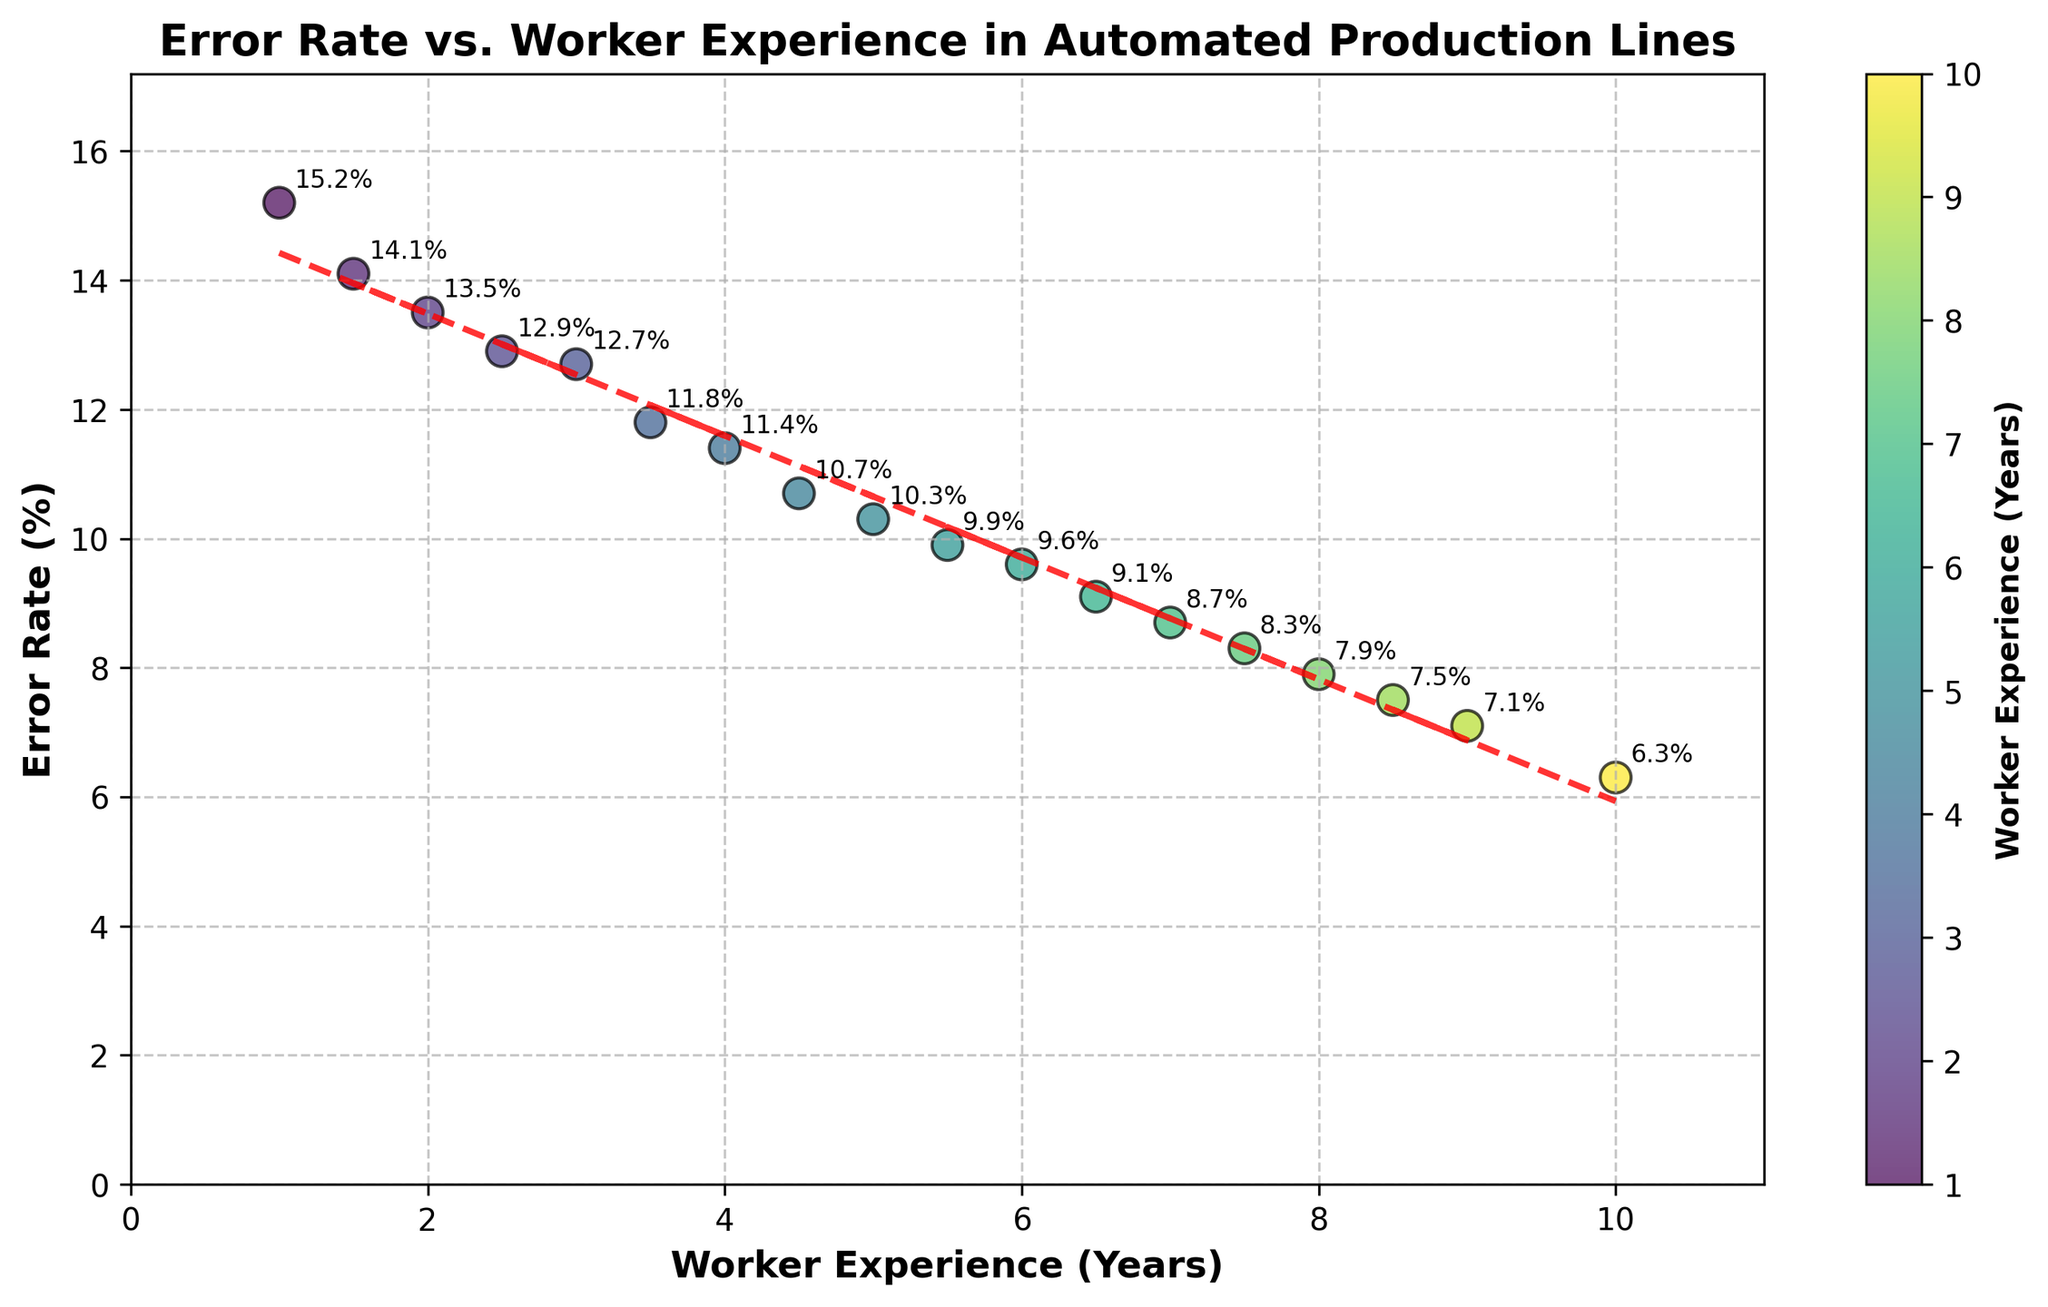What is the overall trend of error rate as worker experience increases? The trend can be observed by looking at the red dashed line representing the linear regression. The line has a negative slope, indicating that the error rate tends to decrease as worker experience increases.
Answer: Decreasing What are the highest and lowest error rates observed in the dataset? The highest and lowest error rates can be identified by looking at the y-axis and the points on the plot. The highest error rate is 15.2% for workers with 1 year of experience, and the lowest error rate is 6.3% for workers with 10 years of experience.
Answer: Highest: 15.2%, Lowest: 6.3% How many data points are there on the plot? The number of data points can be determined by counting the individual scatter points on the plot. There are 18 data points.
Answer: 18 What is the error rate for workers with 5 years of experience? Find the point on the scatter plot corresponding to 5 years on the x-axis and note its y-value. The error rate for workers with 5 years of experience is 10.3%.
Answer: 10.3% Which worker experience group (given in years) has the most significant variation in error rates? The variation in error rates for each worker experience group can be accessed by observing the distribution and spread of the points. Workers with 1-2 years of experience show significant variation compared to more experienced groups.
Answer: 1-2 years What is the approximate slope of the trend line? The slope of the trend line can be estimated by observing its direction and gradient. The line seems to drop slightly for every unit increase in experience. The exact slope is about -1.
Answer: -1 How does the color of the scatter points relate to the data? The color of the scatter points indicates the worker's experience, with the color gradient shown in the color bar. Darker colors represent less experience, while lighter colors represent more experience.
Answer: Represents experience Is there any anomaly or outlier present in the data? By examining the data points, significant deviations from the trend line show potential outliers. The point at 1 year experience and 15.2% error rate seems like an outlier.
Answer: 1 year, 15.2% What is the general shape/appearance of the scatter plot points' distribution? The general shape of the distribution of the scatter points follows a downward trend moving from left to right. The points are fairly evenly spread along the trend line.
Answer: Downward trend Which worker experience group (in years) shows the least error rate, and what is it? By looking at the scatter points and reading the y-values, the workers with 10 years of experience show the least error rate, which is 6.3%.
Answer: 10 years, 6.3% 